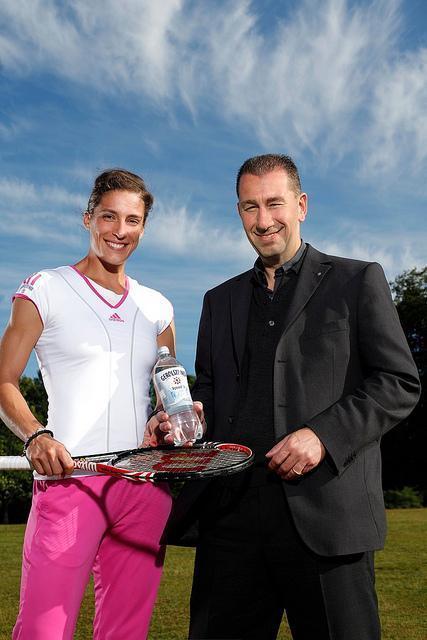How many people are in the photo?
Give a very brief answer. 2. 